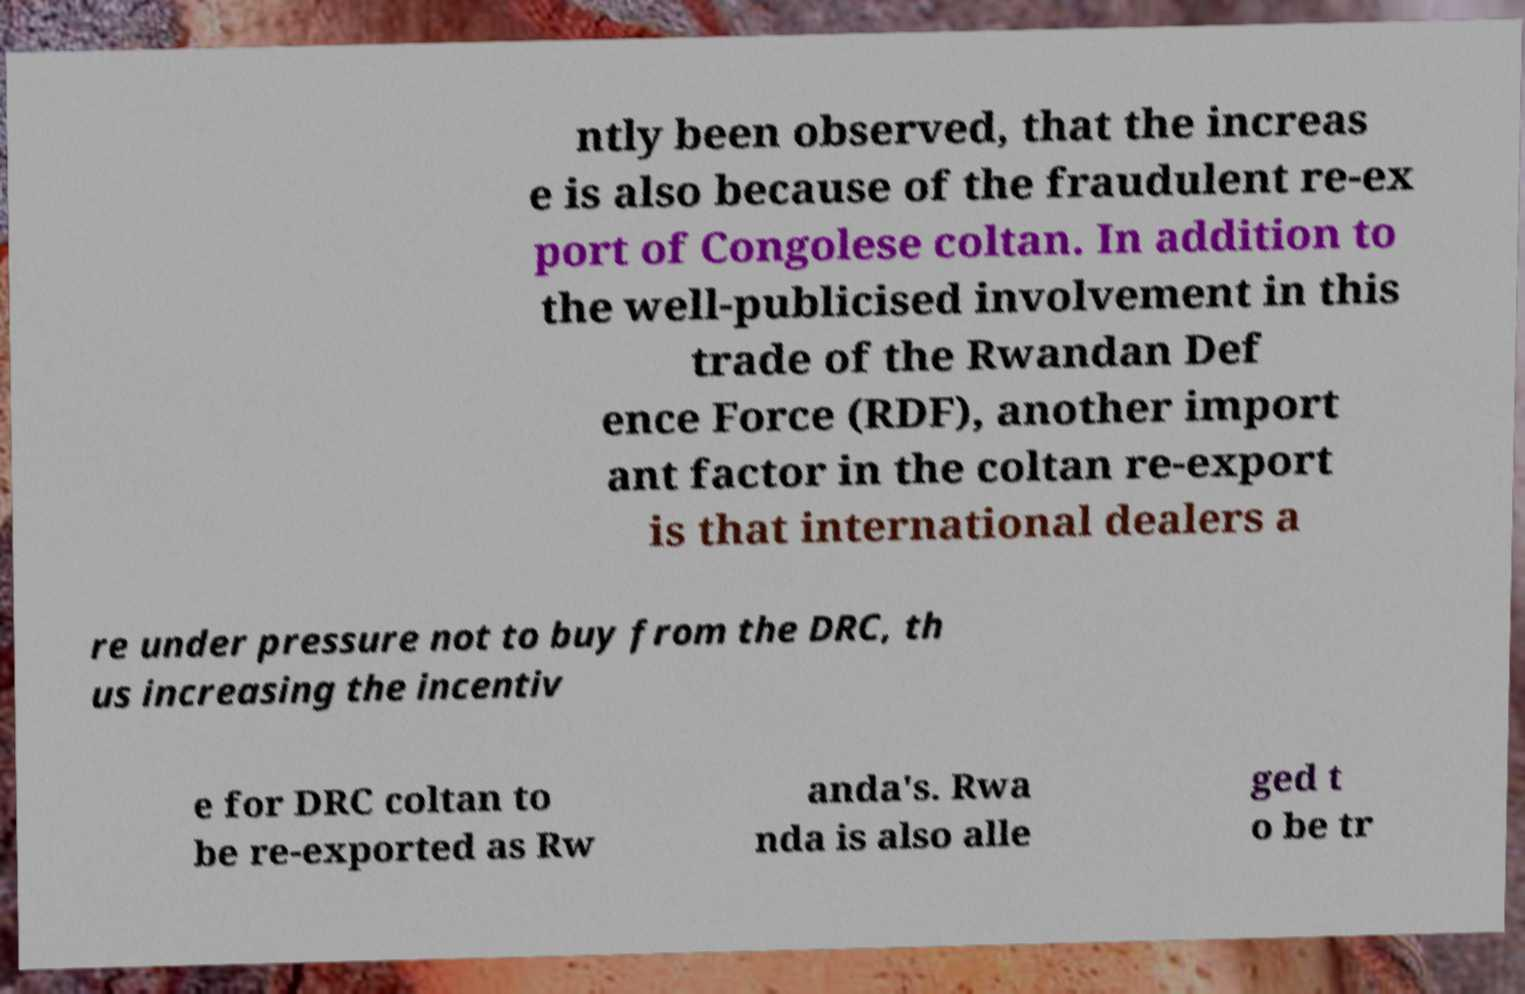I need the written content from this picture converted into text. Can you do that? ntly been observed, that the increas e is also because of the fraudulent re-ex port of Congolese coltan. In addition to the well-publicised involvement in this trade of the Rwandan Def ence Force (RDF), another import ant factor in the coltan re-export is that international dealers a re under pressure not to buy from the DRC, th us increasing the incentiv e for DRC coltan to be re-exported as Rw anda's. Rwa nda is also alle ged t o be tr 